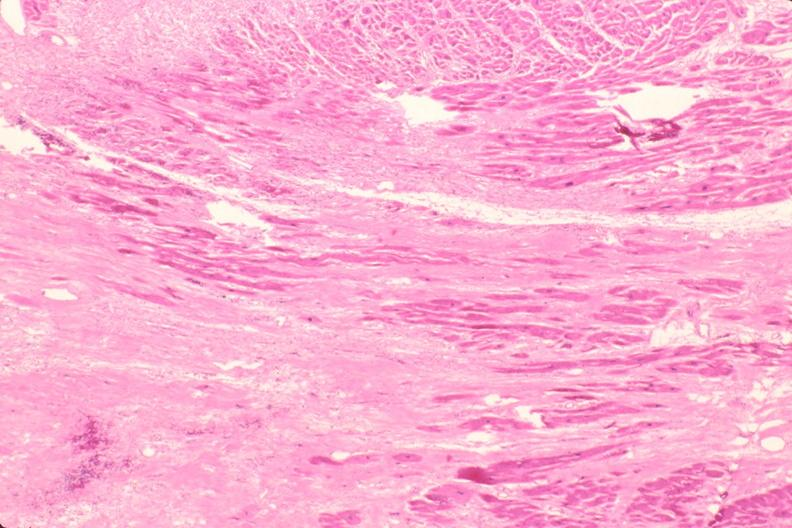what does this image show?
Answer the question using a single word or phrase. Heart 